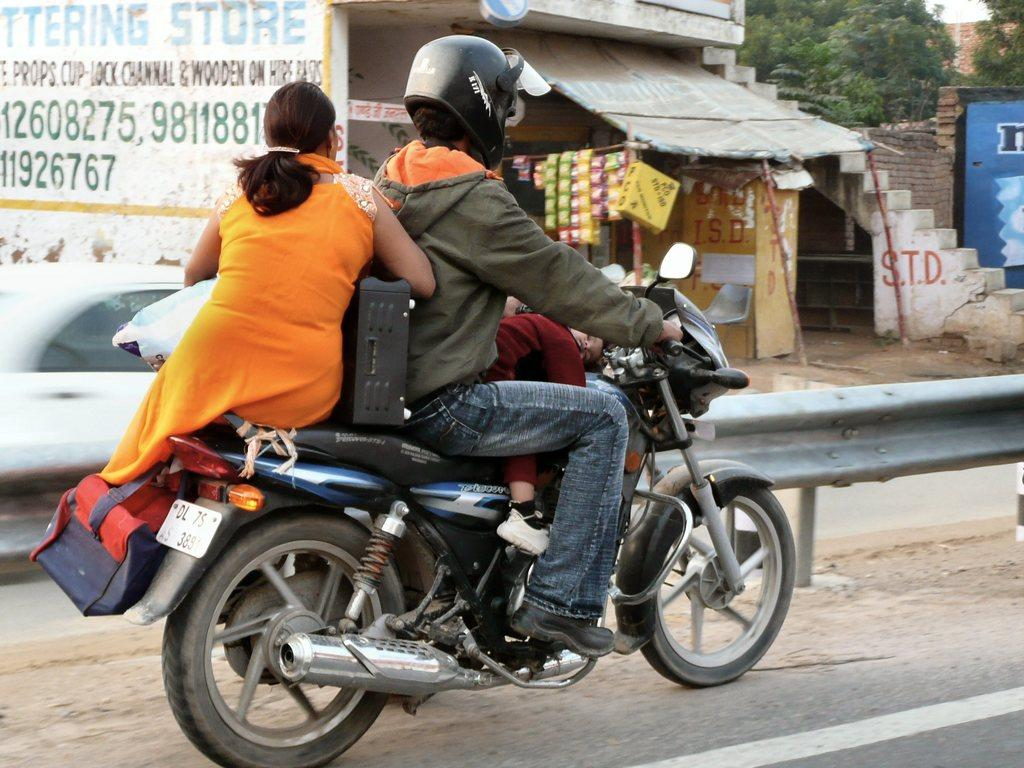What is the main subject of the image? The main subject of the image is a bike. How many people are on the bike? There are three people on the bike. What can be seen in the background of the image? There is a shop and trees in the background of the image. What type of steel is used to make the pancake in the image? There is no pancake present in the image, and therefore no steel or pancake can be observed. 